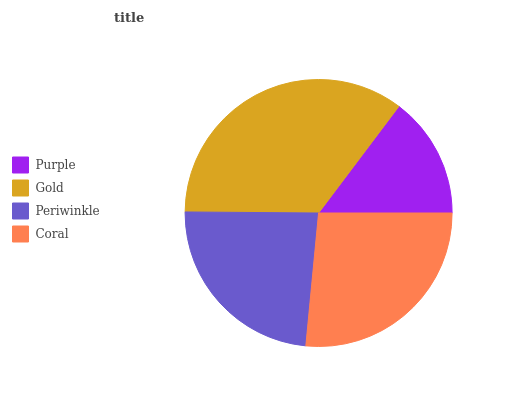Is Purple the minimum?
Answer yes or no. Yes. Is Gold the maximum?
Answer yes or no. Yes. Is Periwinkle the minimum?
Answer yes or no. No. Is Periwinkle the maximum?
Answer yes or no. No. Is Gold greater than Periwinkle?
Answer yes or no. Yes. Is Periwinkle less than Gold?
Answer yes or no. Yes. Is Periwinkle greater than Gold?
Answer yes or no. No. Is Gold less than Periwinkle?
Answer yes or no. No. Is Coral the high median?
Answer yes or no. Yes. Is Periwinkle the low median?
Answer yes or no. Yes. Is Gold the high median?
Answer yes or no. No. Is Coral the low median?
Answer yes or no. No. 